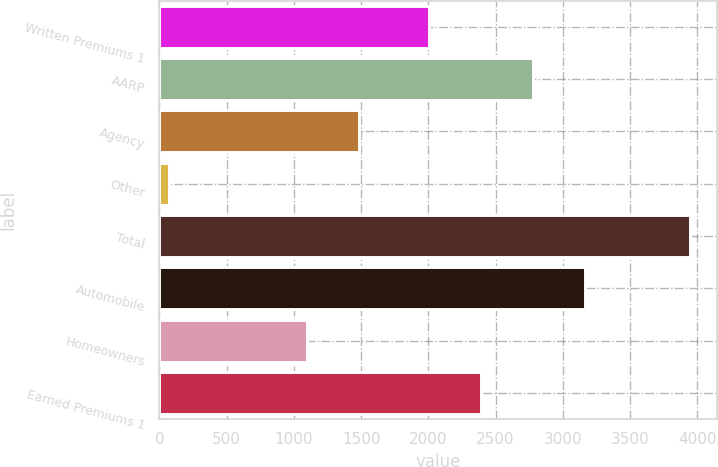Convert chart to OTSL. <chart><loc_0><loc_0><loc_500><loc_500><bar_chart><fcel>Written Premiums 1<fcel>AARP<fcel>Agency<fcel>Other<fcel>Total<fcel>Automobile<fcel>Homeowners<fcel>Earned Premiums 1<nl><fcel>2007<fcel>2781.6<fcel>1486.3<fcel>74<fcel>3947<fcel>3168.9<fcel>1099<fcel>2394.3<nl></chart> 